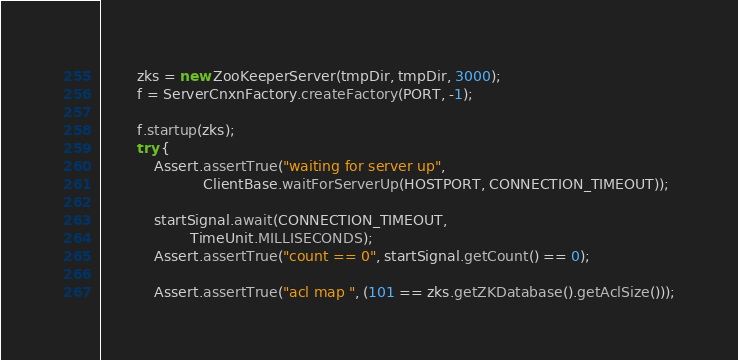Convert code to text. <code><loc_0><loc_0><loc_500><loc_500><_Java_>        zks = new ZooKeeperServer(tmpDir, tmpDir, 3000);
        f = ServerCnxnFactory.createFactory(PORT, -1);

        f.startup(zks);
        try {
            Assert.assertTrue("waiting for server up",
                       ClientBase.waitForServerUp(HOSTPORT, CONNECTION_TIMEOUT));
    
            startSignal.await(CONNECTION_TIMEOUT,
                    TimeUnit.MILLISECONDS);
            Assert.assertTrue("count == 0", startSignal.getCount() == 0);
    
            Assert.assertTrue("acl map ", (101 == zks.getZKDatabase().getAclSize()));</code> 